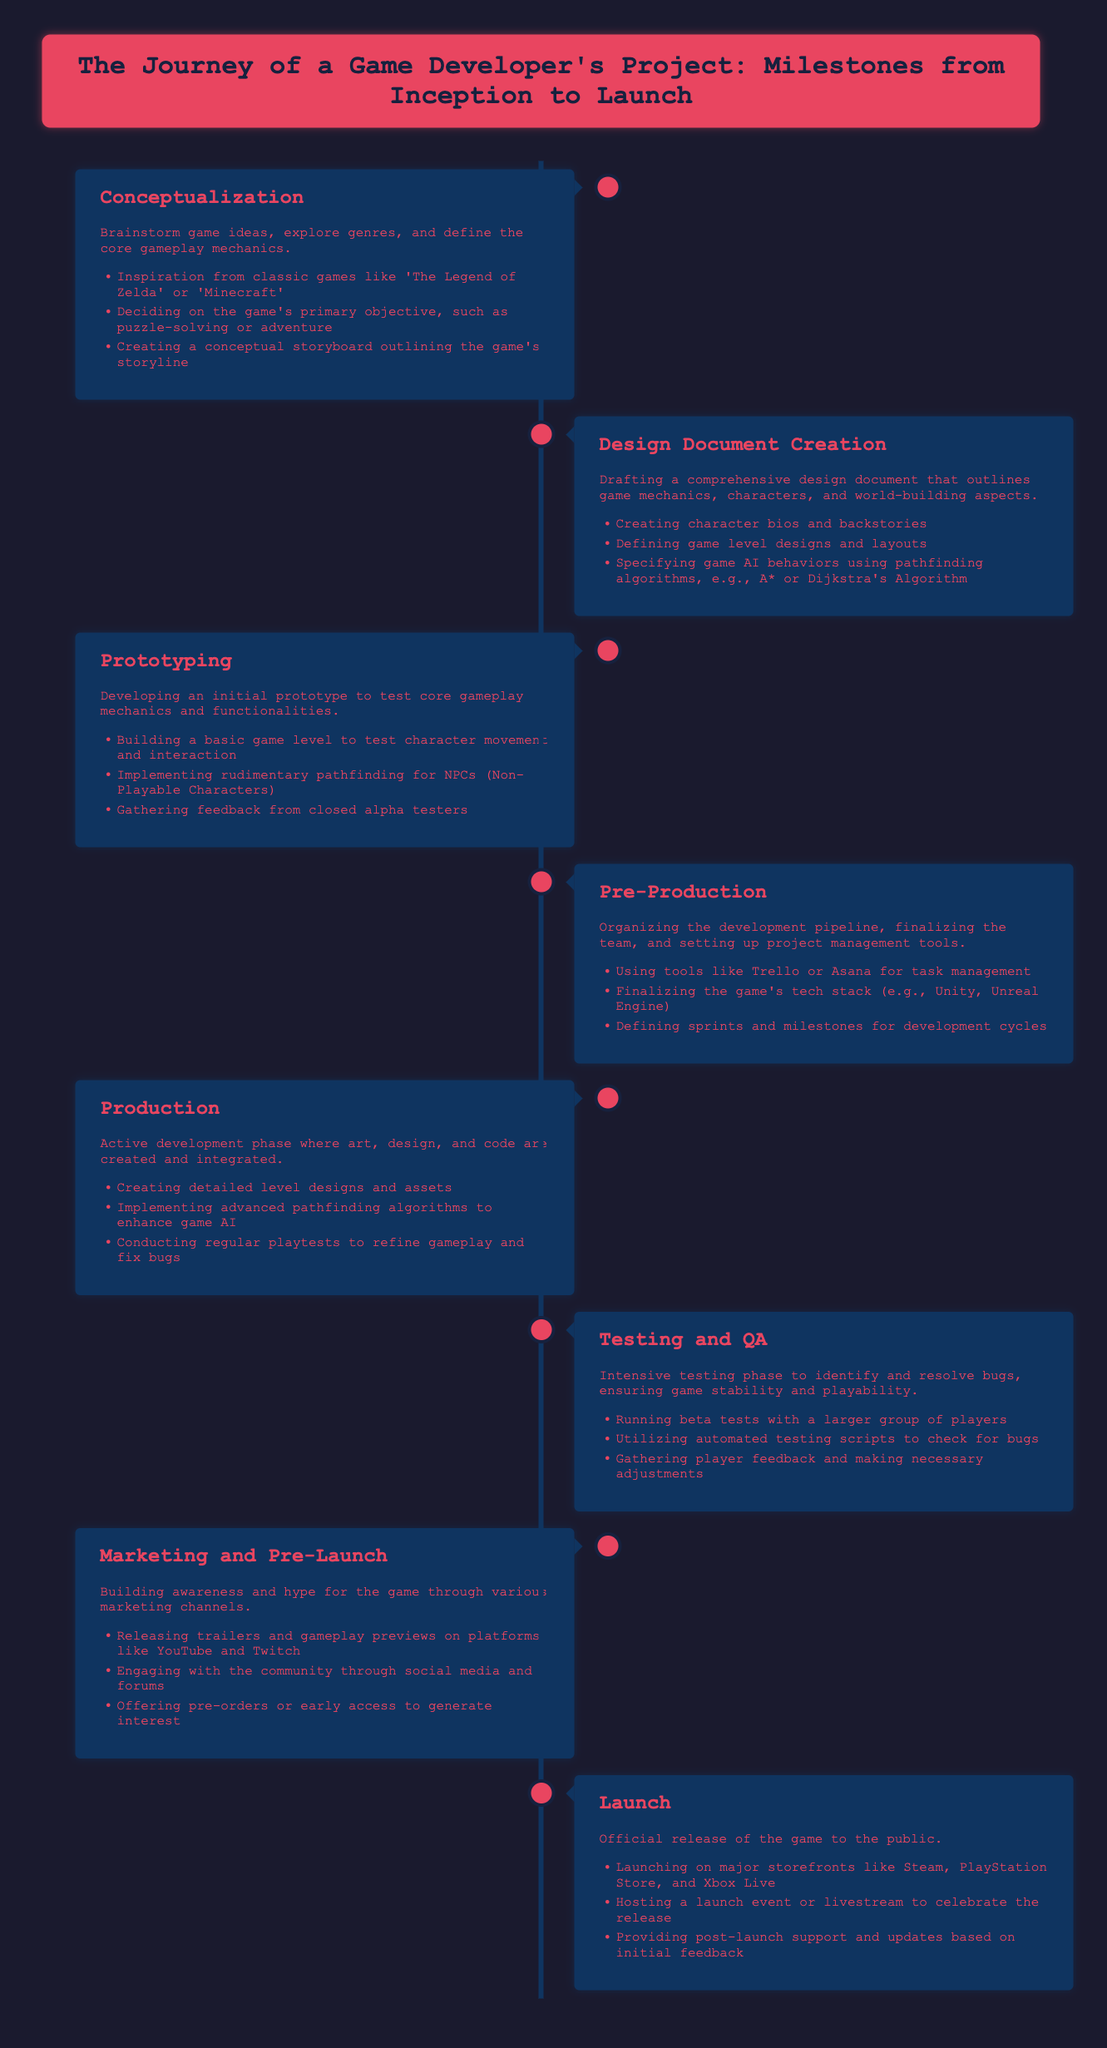What is the first milestone in the journey? The first milestone listed in the document is 'Conceptualization.'
Answer: Conceptualization What document outlines game mechanics and characters? The document refers to a 'Design Document' that outlines game mechanics and characters.
Answer: Design Document Which phase involves gathering feedback from closed alpha testers? The phase called 'Prototyping' includes gathering feedback from closed alpha testers.
Answer: Prototyping What is the primary focus during the 'Testing and QA' phase? The primary focus during this phase is to identify and resolve bugs.
Answer: Identify and resolve bugs What is created during the 'Production' milestone? The document states that detailed level designs and assets are created during the 'Production' milestone.
Answer: Detailed level designs and assets Which phase involves using tools like Trello or Asana? The 'Pre-Production' phase involves organizing the development pipeline and using tools like Trello or Asana.
Answer: Pre-Production How many milestones are listed in the document? There are a total of eight milestones listed in the journey of a game developer's project.
Answer: Eight What kind of algorithms are specified to enhance game AI? The document specifies advanced pathfinding algorithms to enhance game AI.
Answer: Pathfinding algorithms What event may be hosted to celebrate the release? A launch event or livestream may be hosted to celebrate the game's release.
Answer: Launch event or livestream 